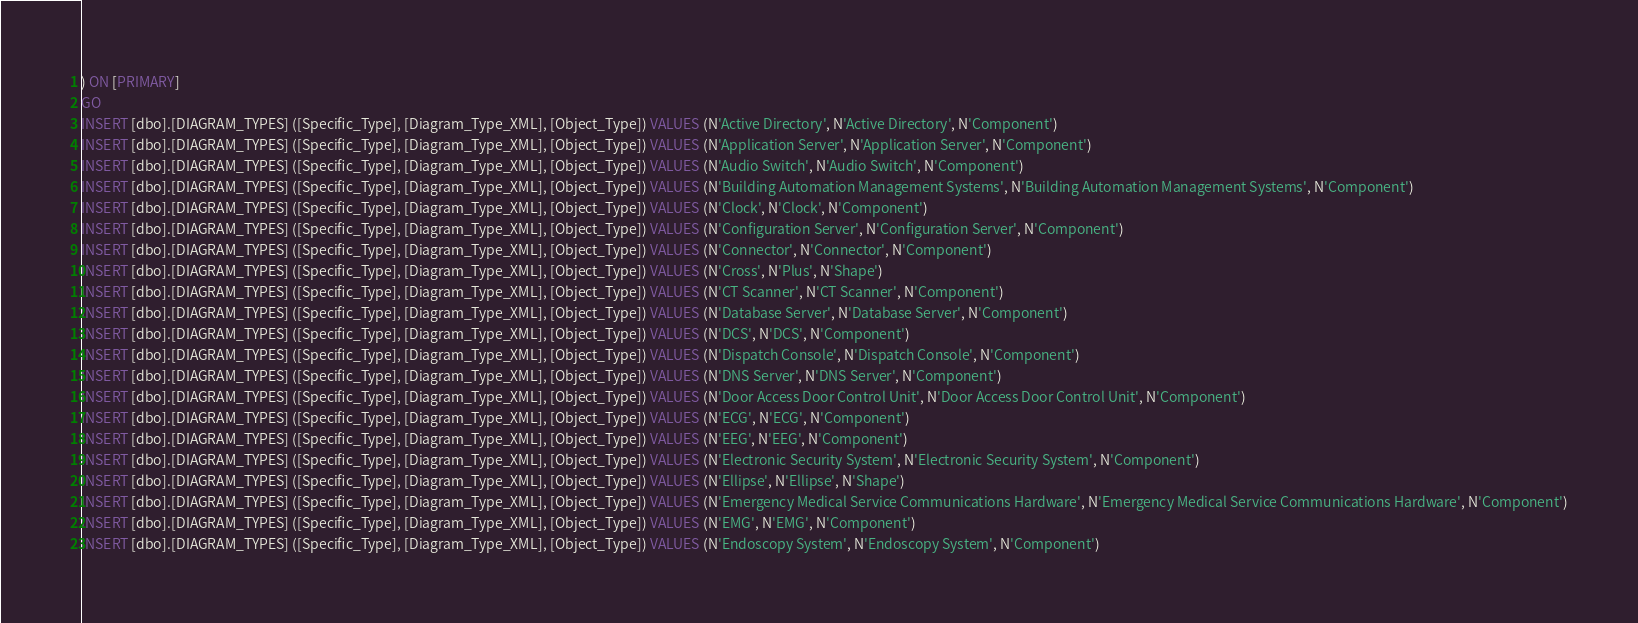Convert code to text. <code><loc_0><loc_0><loc_500><loc_500><_SQL_>) ON [PRIMARY]
GO
INSERT [dbo].[DIAGRAM_TYPES] ([Specific_Type], [Diagram_Type_XML], [Object_Type]) VALUES (N'Active Directory', N'Active Directory', N'Component')
INSERT [dbo].[DIAGRAM_TYPES] ([Specific_Type], [Diagram_Type_XML], [Object_Type]) VALUES (N'Application Server', N'Application Server', N'Component')
INSERT [dbo].[DIAGRAM_TYPES] ([Specific_Type], [Diagram_Type_XML], [Object_Type]) VALUES (N'Audio Switch', N'Audio Switch', N'Component')
INSERT [dbo].[DIAGRAM_TYPES] ([Specific_Type], [Diagram_Type_XML], [Object_Type]) VALUES (N'Building Automation Management Systems', N'Building Automation Management Systems', N'Component')
INSERT [dbo].[DIAGRAM_TYPES] ([Specific_Type], [Diagram_Type_XML], [Object_Type]) VALUES (N'Clock', N'Clock', N'Component')
INSERT [dbo].[DIAGRAM_TYPES] ([Specific_Type], [Diagram_Type_XML], [Object_Type]) VALUES (N'Configuration Server', N'Configuration Server', N'Component')
INSERT [dbo].[DIAGRAM_TYPES] ([Specific_Type], [Diagram_Type_XML], [Object_Type]) VALUES (N'Connector', N'Connector', N'Component')
INSERT [dbo].[DIAGRAM_TYPES] ([Specific_Type], [Diagram_Type_XML], [Object_Type]) VALUES (N'Cross', N'Plus', N'Shape')
INSERT [dbo].[DIAGRAM_TYPES] ([Specific_Type], [Diagram_Type_XML], [Object_Type]) VALUES (N'CT Scanner', N'CT Scanner', N'Component')
INSERT [dbo].[DIAGRAM_TYPES] ([Specific_Type], [Diagram_Type_XML], [Object_Type]) VALUES (N'Database Server', N'Database Server', N'Component')
INSERT [dbo].[DIAGRAM_TYPES] ([Specific_Type], [Diagram_Type_XML], [Object_Type]) VALUES (N'DCS', N'DCS', N'Component')
INSERT [dbo].[DIAGRAM_TYPES] ([Specific_Type], [Diagram_Type_XML], [Object_Type]) VALUES (N'Dispatch Console', N'Dispatch Console', N'Component')
INSERT [dbo].[DIAGRAM_TYPES] ([Specific_Type], [Diagram_Type_XML], [Object_Type]) VALUES (N'DNS Server', N'DNS Server', N'Component')
INSERT [dbo].[DIAGRAM_TYPES] ([Specific_Type], [Diagram_Type_XML], [Object_Type]) VALUES (N'Door Access Door Control Unit', N'Door Access Door Control Unit', N'Component')
INSERT [dbo].[DIAGRAM_TYPES] ([Specific_Type], [Diagram_Type_XML], [Object_Type]) VALUES (N'ECG', N'ECG', N'Component')
INSERT [dbo].[DIAGRAM_TYPES] ([Specific_Type], [Diagram_Type_XML], [Object_Type]) VALUES (N'EEG', N'EEG', N'Component')
INSERT [dbo].[DIAGRAM_TYPES] ([Specific_Type], [Diagram_Type_XML], [Object_Type]) VALUES (N'Electronic Security System', N'Electronic Security System', N'Component')
INSERT [dbo].[DIAGRAM_TYPES] ([Specific_Type], [Diagram_Type_XML], [Object_Type]) VALUES (N'Ellipse', N'Ellipse', N'Shape')
INSERT [dbo].[DIAGRAM_TYPES] ([Specific_Type], [Diagram_Type_XML], [Object_Type]) VALUES (N'Emergency Medical Service Communications Hardware', N'Emergency Medical Service Communications Hardware', N'Component')
INSERT [dbo].[DIAGRAM_TYPES] ([Specific_Type], [Diagram_Type_XML], [Object_Type]) VALUES (N'EMG', N'EMG', N'Component')
INSERT [dbo].[DIAGRAM_TYPES] ([Specific_Type], [Diagram_Type_XML], [Object_Type]) VALUES (N'Endoscopy System', N'Endoscopy System', N'Component')</code> 